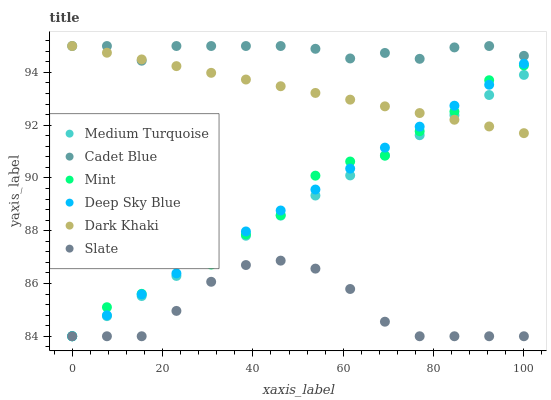Does Slate have the minimum area under the curve?
Answer yes or no. Yes. Does Cadet Blue have the maximum area under the curve?
Answer yes or no. Yes. Does Medium Turquoise have the minimum area under the curve?
Answer yes or no. No. Does Medium Turquoise have the maximum area under the curve?
Answer yes or no. No. Is Deep Sky Blue the smoothest?
Answer yes or no. Yes. Is Mint the roughest?
Answer yes or no. Yes. Is Medium Turquoise the smoothest?
Answer yes or no. No. Is Medium Turquoise the roughest?
Answer yes or no. No. Does Medium Turquoise have the lowest value?
Answer yes or no. Yes. Does Dark Khaki have the lowest value?
Answer yes or no. No. Does Dark Khaki have the highest value?
Answer yes or no. Yes. Does Medium Turquoise have the highest value?
Answer yes or no. No. Is Slate less than Cadet Blue?
Answer yes or no. Yes. Is Cadet Blue greater than Medium Turquoise?
Answer yes or no. Yes. Does Medium Turquoise intersect Deep Sky Blue?
Answer yes or no. Yes. Is Medium Turquoise less than Deep Sky Blue?
Answer yes or no. No. Is Medium Turquoise greater than Deep Sky Blue?
Answer yes or no. No. Does Slate intersect Cadet Blue?
Answer yes or no. No. 